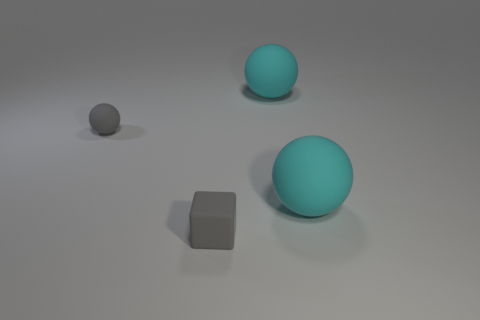There is a rubber thing that is the same size as the gray rubber ball; what shape is it?
Your response must be concise. Cube. Are there fewer blocks than large cyan balls?
Make the answer very short. Yes. What number of yellow metallic cubes have the same size as the gray cube?
Provide a succinct answer. 0. There is a rubber object that is the same color as the small cube; what shape is it?
Offer a terse response. Sphere. There is a matte thing behind the small ball; what size is it?
Your response must be concise. Large. There is a gray thing that is made of the same material as the tiny gray sphere; what is its shape?
Keep it short and to the point. Cube. How many purple objects are spheres or matte cylinders?
Make the answer very short. 0. Are there any tiny gray rubber objects on the right side of the gray matte block?
Offer a very short reply. No. There is a big matte thing behind the tiny gray ball; does it have the same shape as the matte object that is on the left side of the gray block?
Ensure brevity in your answer.  Yes. How many blocks are matte things or small gray rubber things?
Ensure brevity in your answer.  1. 